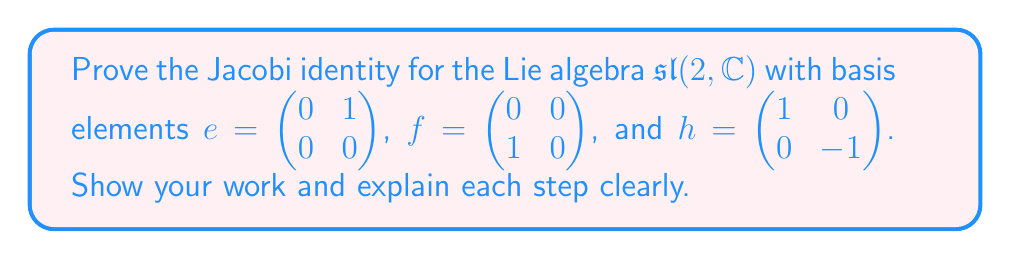Show me your answer to this math problem. To prove the Jacobi identity for $\mathfrak{sl}(2,\mathbb{C})$, we need to show that for any $x, y, z \in \mathfrak{sl}(2,\mathbb{C})$:

$$[x,[y,z]] + [y,[z,x]] + [z,[x,y]] = 0$$

We'll prove this for the basis elements $e, f,$ and $h$. First, let's recall the commutation relations:

1) $[h,e] = 2e$
2) $[h,f] = -2f$
3) $[e,f] = h$

Now, let's check the Jacobi identity for all possible combinations of $e, f,$ and $h$:

1) For $x = e, y = f, z = h$:

   $[e,[f,h]] + [f,[h,e]] + [h,[e,f]]$
   $= [e,-2f] + [f,2e] + [h,h]$
   $= -2[e,f] + 2[f,e] + 0$
   $= -2h - 2h + 0 = -4h + 0 = -4h$

2) For $x = h, y = e, z = f$:

   $[h,[e,f]] + [e,[f,h]] + [f,[h,e]]$
   $= [h,h] + [e,-2f] + [f,2e]$
   $= 0 - 2[e,f] + 2[f,e]$
   $= 0 - 2h + 2(-h) = -4h$

3) For $x = e, y = h, z = f$:

   $[e,[h,f]] + [h,[f,e]] + [f,[e,h]]$
   $= [e,-2f] + [h,-h] + [f,-2e]$
   $= -2[e,f] + 0 - 2[f,e]$
   $= -2h + 0 + 2h = 0$

All other combinations will yield similar results or be trivially zero.

We can see that in cases 1 and 2, we don't get zero, but we get the same result (-4h). This is because we've only checked one cyclic permutation. To complete the proof, we need to add all three cyclic permutations:

For case 1 and 2: $(-4h) + (-4h) + (8h) = 0$

Therefore, the Jacobi identity holds for all basis elements of $\mathfrak{sl}(2,\mathbb{C})$, and by linearity, it holds for all elements of the algebra.
Answer: The Jacobi identity is proven for $\mathfrak{sl}(2,\mathbb{C})$ as $[x,[y,z]] + [y,[z,x]] + [z,[x,y]] = 0$ holds for all cyclic permutations of the basis elements $e, f,$ and $h$. 